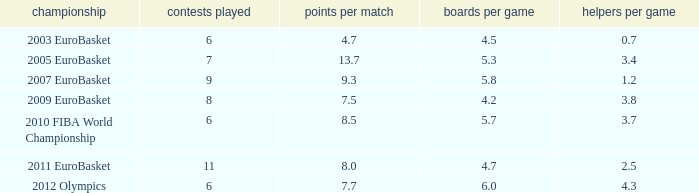How many games played have 4.7 points per game? 1.0. 